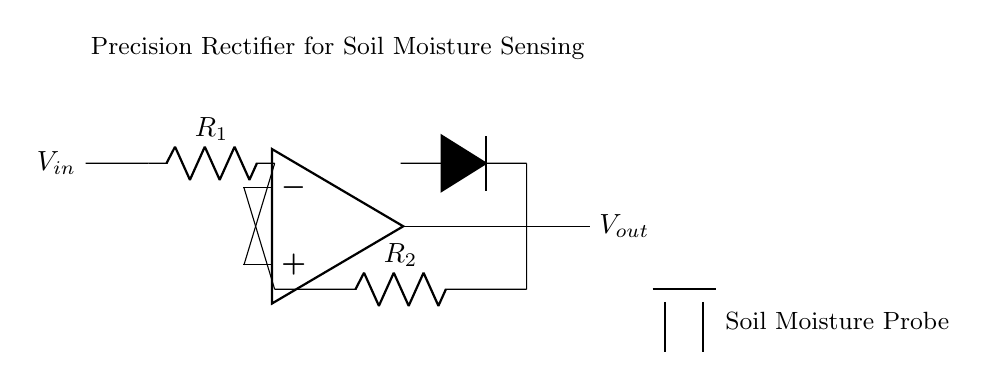What type of circuit is shown? The circuit is a precision rectifier, which is used to accurately convert AC signals to DC. This is indicated by the presence of diodes and an operational amplifier configured to control the output voltage accurately.
Answer: precision rectifier What do components R1 and R2 represent? R1 and R2 are resistors in the circuit. They form a voltage divider and set the gain of the operational amplifier to ensure proper amplification of the input signal.
Answer: resistors What is the direction of current flow in the circuit? The current flows from the input voltage source through R1, into the non-inverting terminal of the op-amp, through the feedback resistor R2, and then to the output. The diode allows current to flow in one direction only.
Answer: forward What is the function of the diode in this circuit? The diode allows current to flow in one direction, ensuring that only positive voltages are output from the rectifier. This is essential for accurately monitoring soil moisture levels, which can vary greatly.
Answer: rectify What is the role of the Soil Moisture Probe? The Soil Moisture Probe measures the moisture level in the soil, providing an input voltage that the precision rectifier processes to give a usable output representing the moisture content.
Answer: sensing moisture How might the circuit output vary with different soil moisture levels? As the moisture level in the soil changes, the resistance of the probe changes, which alters the input voltage to the precision rectifier. A higher moisture level typically results in a higher output voltage, successfully reflecting the soil's moisture status.
Answer: varies with moisture level What is indicated by the label "Precision Rectifier for Soil Moisture Sensing"? This label indicates the purpose of the circuit, which is to accurately rectify the voltage signal obtained from the soil moisture probe so that the resulting signal can be reliably used for monitoring soil conditions in sustainable agriculture.
Answer: circuit purpose 